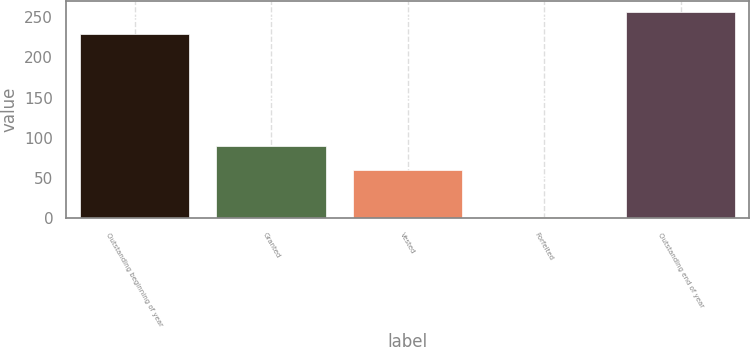<chart> <loc_0><loc_0><loc_500><loc_500><bar_chart><fcel>Outstanding beginning of year<fcel>Granted<fcel>Vested<fcel>Forfeited<fcel>Outstanding end of year<nl><fcel>229<fcel>90<fcel>60<fcel>2<fcel>257<nl></chart> 